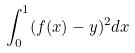<formula> <loc_0><loc_0><loc_500><loc_500>\int _ { 0 } ^ { 1 } ( f ( x ) - y ) ^ { 2 } d x</formula> 